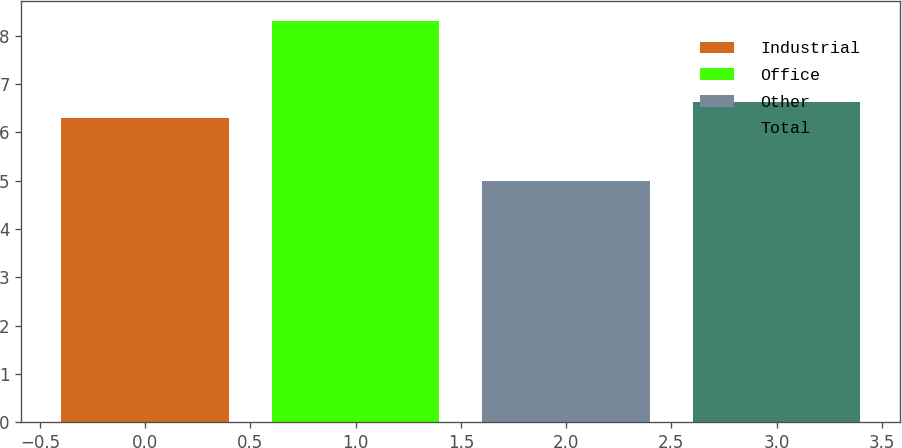Convert chart. <chart><loc_0><loc_0><loc_500><loc_500><bar_chart><fcel>Industrial<fcel>Office<fcel>Other<fcel>Total<nl><fcel>6.3<fcel>8.3<fcel>5<fcel>6.63<nl></chart> 